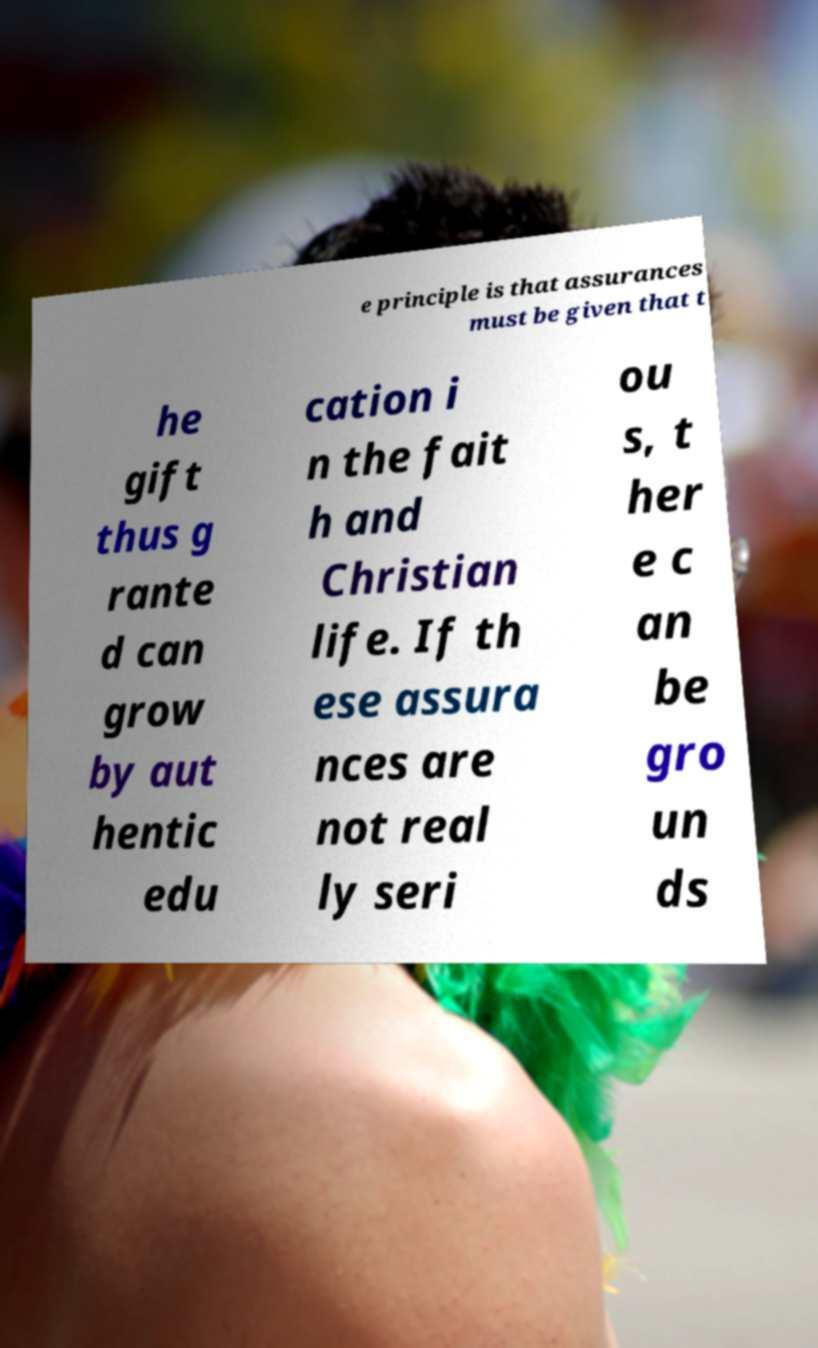For documentation purposes, I need the text within this image transcribed. Could you provide that? e principle is that assurances must be given that t he gift thus g rante d can grow by aut hentic edu cation i n the fait h and Christian life. If th ese assura nces are not real ly seri ou s, t her e c an be gro un ds 